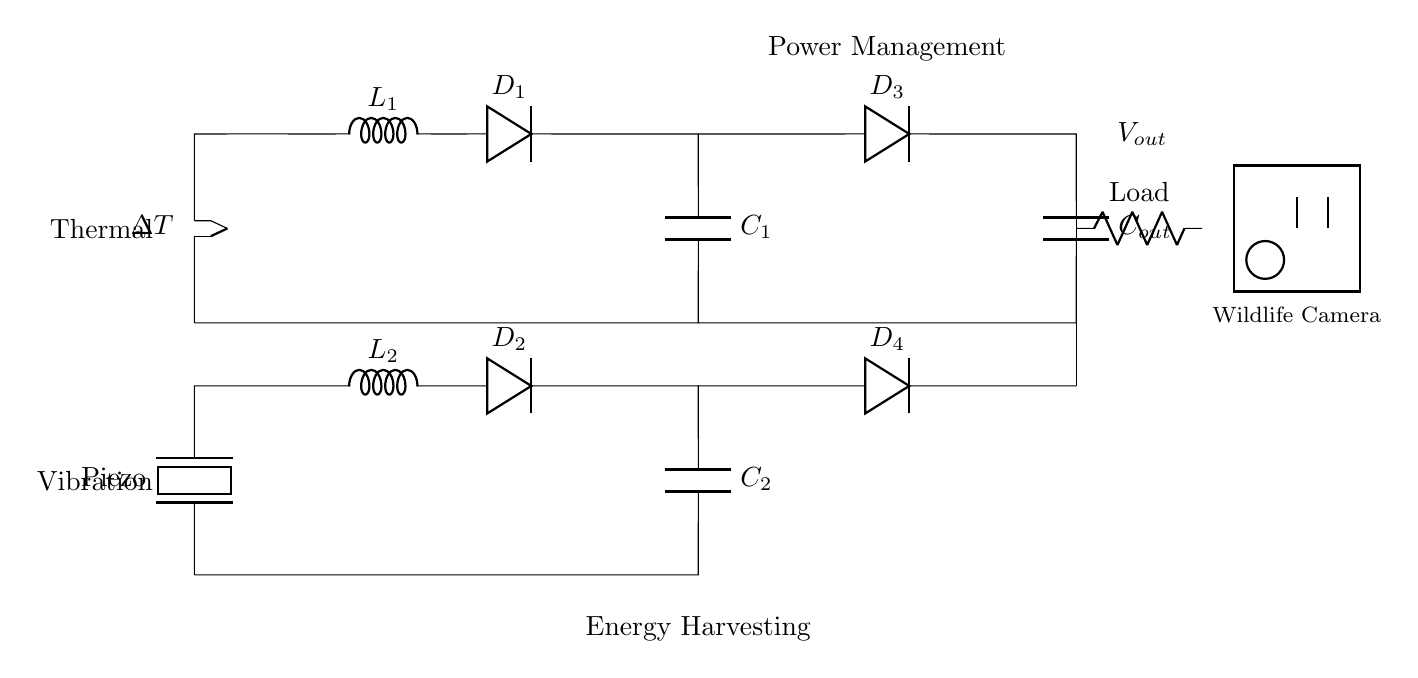What is the main energy source for this circuit? The main energy sources indicated in the circuit are thermal and vibration. The thermal energy harvester is at the top, while the vibration energy harvester is at the bottom.
Answer: Thermal and vibration What is the function of the components labeled L1 and L2? L1 and L2 are inductors used in the thermal and vibration energy harvesting sections respectively. They store energy generated from their respective sources.
Answer: Inductors How many diodes are present in the circuit? There are four diodes in total identified as D1, D2, D3, and D4. Each serves to control the flow of current in the respective sections of the circuit.
Answer: Four What is the purpose of the capacitor labeled Cout? The capacitor Cout is used for energy storage before supplying power to the load. It stabilizes the output voltage to the wildlife camera.
Answer: Energy storage Which component represents the load of the circuit? The load of the circuit is represented by the resistor labeled Load. This component takes in the power supplied by the energy harvesting section for the wildlife camera.
Answer: Resistor What type of energy does the piezoelectric element convert? The piezoelectric element converts mechanical vibration into electrical energy. It is an integral part of the vibration energy harvesting segment.
Answer: Mechanical to electrical Explain the role of the power management portion of the circuit. The power management section, consisting of diodes D3 and D4 and other components, ensures that the electrical energy from both energy sources is effectively utilized and distributed to the output load without overloading. It regulates and combines the energy outputs from the harvesting sources.
Answer: Energy regulation 